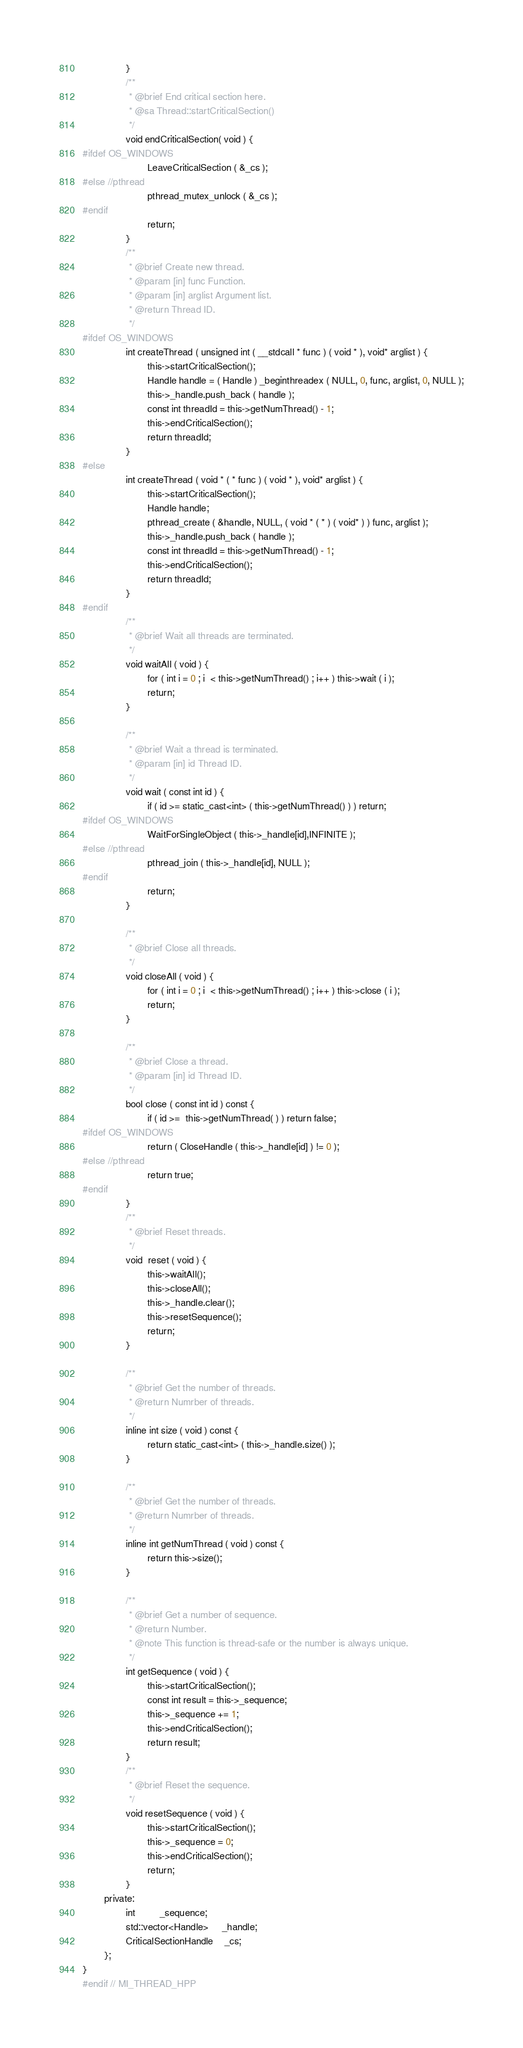<code> <loc_0><loc_0><loc_500><loc_500><_C++_>                }
                /**
                 * @brief End critical section here.
                 * @sa Thread::startCriticalSection()
                 */
                void endCriticalSection( void ) {
#ifdef OS_WINDOWS
                        LeaveCriticalSection ( &_cs );
#else //pthread
                        pthread_mutex_unlock ( &_cs );
#endif
                        return;
                }
                /**
                 * @brief Create new thread.
                 * @param [in] func Function.
                 * @param [in] arglist Argument list.
                 * @return Thread ID.
                 */
#ifdef OS_WINDOWS
                int createThread ( unsigned int ( __stdcall * func ) ( void * ), void* arglist ) {
                        this->startCriticalSection();
                        Handle handle = ( Handle ) _beginthreadex ( NULL, 0, func, arglist, 0, NULL );
                        this->_handle.push_back ( handle );
                        const int threadId = this->getNumThread() - 1;
                        this->endCriticalSection();
                        return threadId;
                }
#else
                int createThread ( void * ( * func ) ( void * ), void* arglist ) {
                        this->startCriticalSection();
                        Handle handle;
                        pthread_create ( &handle, NULL, ( void * ( * ) ( void* ) ) func, arglist );
                        this->_handle.push_back ( handle );
                        const int threadId = this->getNumThread() - 1;
                        this->endCriticalSection();
                        return threadId;
                }
#endif
                /**
                 * @brief Wait all threads are terminated.
                 */
                void waitAll ( void ) {
                        for ( int i = 0 ; i  < this->getNumThread() ; i++ ) this->wait ( i );
                        return;
                }

                /**
                 * @brief Wait a thread is terminated.
                 * @param [in] id Thread ID.
                 */
                void wait ( const int id ) {
                        if ( id >= static_cast<int> ( this->getNumThread() ) ) return;
#ifdef OS_WINDOWS
                        WaitForSingleObject ( this->_handle[id],INFINITE );
#else //pthread
                        pthread_join ( this->_handle[id], NULL );
#endif
                        return;
                }

                /**
                 * @brief Close all threads.
                 */
                void closeAll ( void ) {
                        for ( int i = 0 ; i  < this->getNumThread() ; i++ ) this->close ( i );
                        return;
                }

                /**
                 * @brief Close a thread.
                 * @param [in] id Thread ID.
                 */
                bool close ( const int id ) const {
                        if ( id >=  this->getNumThread( ) ) return false;
#ifdef OS_WINDOWS
                        return ( CloseHandle ( this->_handle[id] ) != 0 );
#else //pthread
                        return true;
#endif
                }
                /**
                 * @brief Reset threads.
                 */
                void  reset ( void ) {
                        this->waitAll();
                        this->closeAll();
                        this->_handle.clear();
                        this->resetSequence();
                        return;
                }

                /**
                 * @brief Get the number of threads.
                 * @return Numrber of threads.
                 */
                inline int size ( void ) const {
                        return static_cast<int> ( this->_handle.size() );
                }

                /**
                 * @brief Get the number of threads.
                 * @return Numrber of threads.
                 */
                inline int getNumThread ( void ) const {
                        return this->size();
                }

                /**
                 * @brief Get a number of sequence.
                 * @return Number.
                 * @note This function is thread-safe or the number is always unique.
                 */
                int getSequence ( void ) {
                        this->startCriticalSection();
                        const int result = this->_sequence;
                        this->_sequence += 1;
                        this->endCriticalSection();
                        return result;
                }
                /**
                 * @brief Reset the sequence.
                 */
                void resetSequence ( void ) {
                        this->startCriticalSection();
                        this->_sequence = 0;
                        this->endCriticalSection();
                        return;
                }
        private:
                int         _sequence;
                std::vector<Handle>     _handle;
                CriticalSectionHandle	_cs;
        };
}
#endif // MI_THREAD_HPP
</code> 